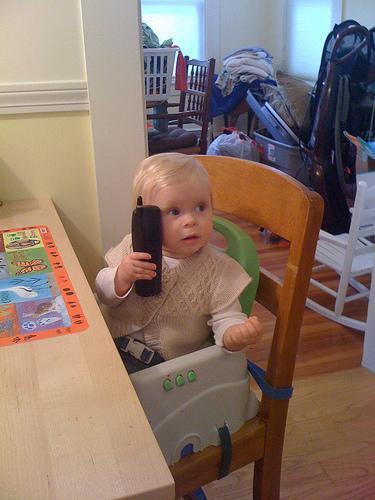How many people are visible in the photo?
Give a very brief answer. 1. 